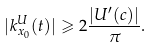Convert formula to latex. <formula><loc_0><loc_0><loc_500><loc_500>| k _ { x _ { 0 } } ^ { U } ( t ) | \geqslant 2 \frac { | U ^ { \prime } ( c ) | } { \pi } .</formula> 